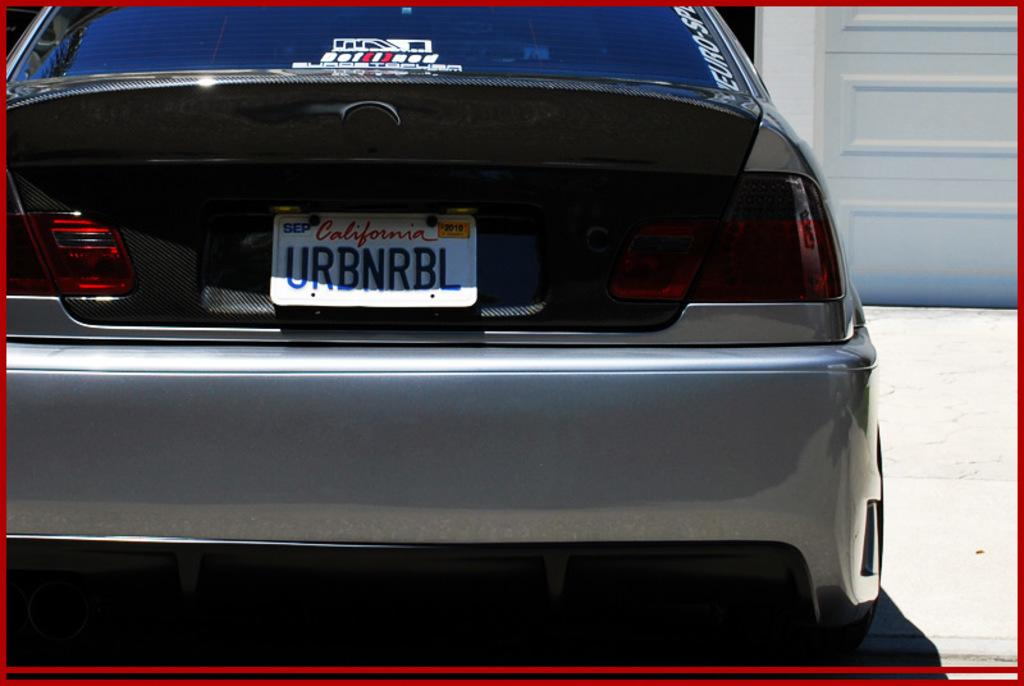<image>
Render a clear and concise summary of the photo. the letters UR start the license plate from California 